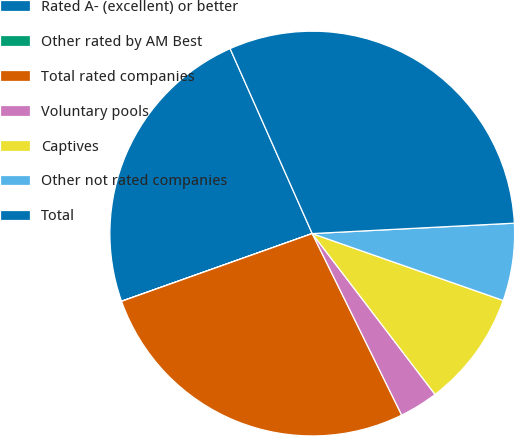Convert chart to OTSL. <chart><loc_0><loc_0><loc_500><loc_500><pie_chart><fcel>Rated A- (excellent) or better<fcel>Other rated by AM Best<fcel>Total rated companies<fcel>Voluntary pools<fcel>Captives<fcel>Other not rated companies<fcel>Total<nl><fcel>23.77%<fcel>0.01%<fcel>26.85%<fcel>3.09%<fcel>9.26%<fcel>6.18%<fcel>30.83%<nl></chart> 